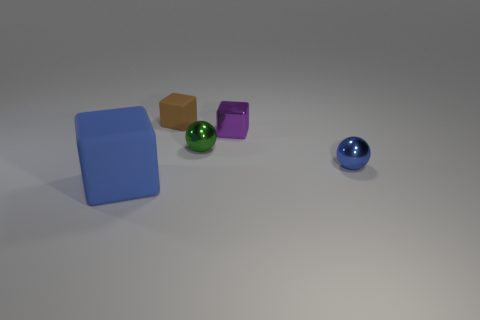Subtract all tiny blocks. How many blocks are left? 1 Subtract all green spheres. How many spheres are left? 1 Add 1 blue rubber objects. How many objects exist? 6 Subtract 1 blocks. How many blocks are left? 2 Subtract all spheres. How many objects are left? 3 Subtract all brown cylinders. How many red cubes are left? 0 Subtract all tiny blue blocks. Subtract all tiny purple blocks. How many objects are left? 4 Add 1 purple metal blocks. How many purple metal blocks are left? 2 Add 2 large purple rubber blocks. How many large purple rubber blocks exist? 2 Subtract 0 green cylinders. How many objects are left? 5 